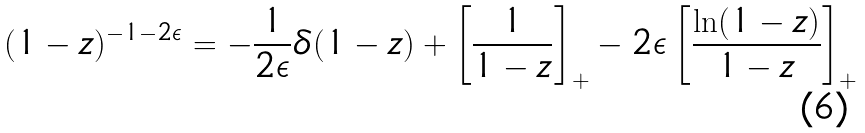<formula> <loc_0><loc_0><loc_500><loc_500>( 1 - z ) ^ { - 1 - 2 \epsilon } = - \frac { 1 } { 2 \epsilon } \delta ( 1 - z ) + \left [ \frac { 1 } { 1 - z } \right ] _ { + } - 2 \epsilon \left [ \frac { \ln ( 1 - z ) } { 1 - z } \right ] _ { + }</formula> 